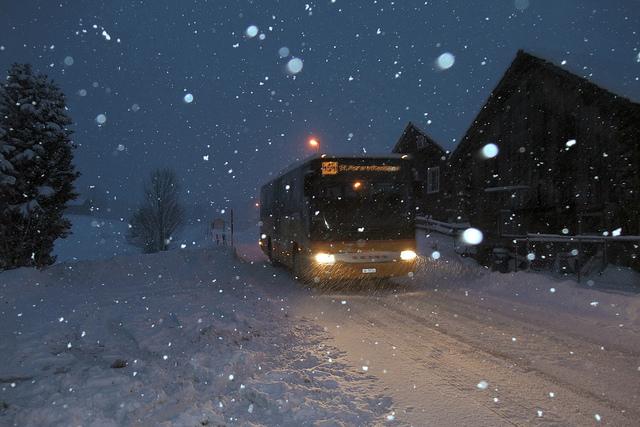Is it nighttime?
Quick response, please. Yes. Are the headlights on?
Keep it brief. Yes. Should this vehicle have on chains?
Quick response, please. Yes. 